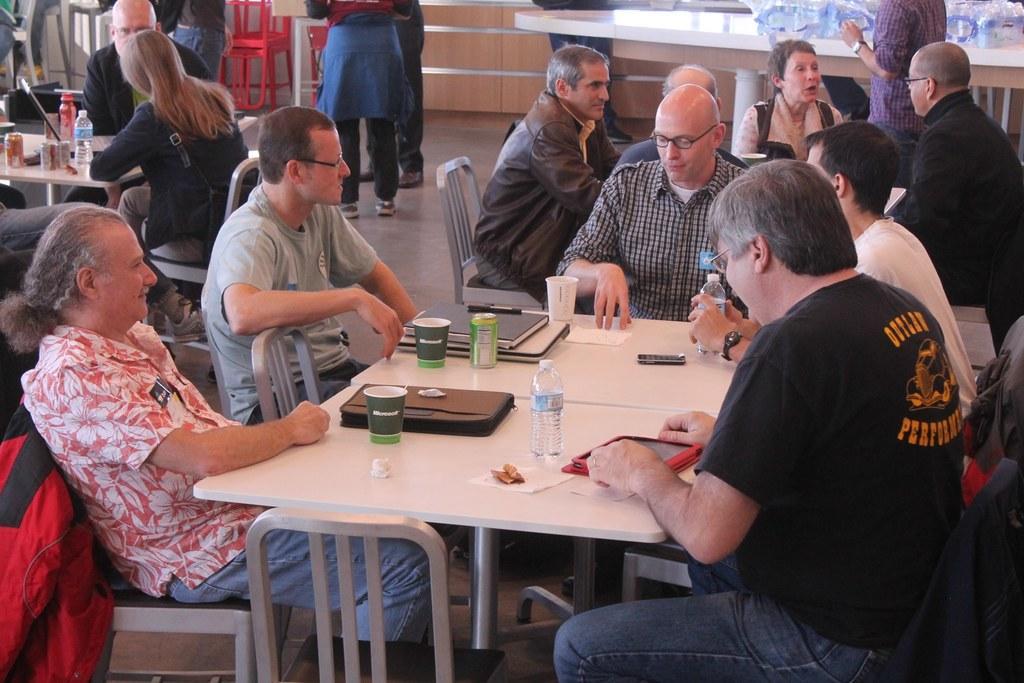Describe this image in one or two sentences. In this picture we can see a group of people sitting on chairs and in front of them on table we have bottles, papers, filed, glasses, tin, remote, pens and in background we can see a table with bottles on it, wall, chairs, some persons standing. 